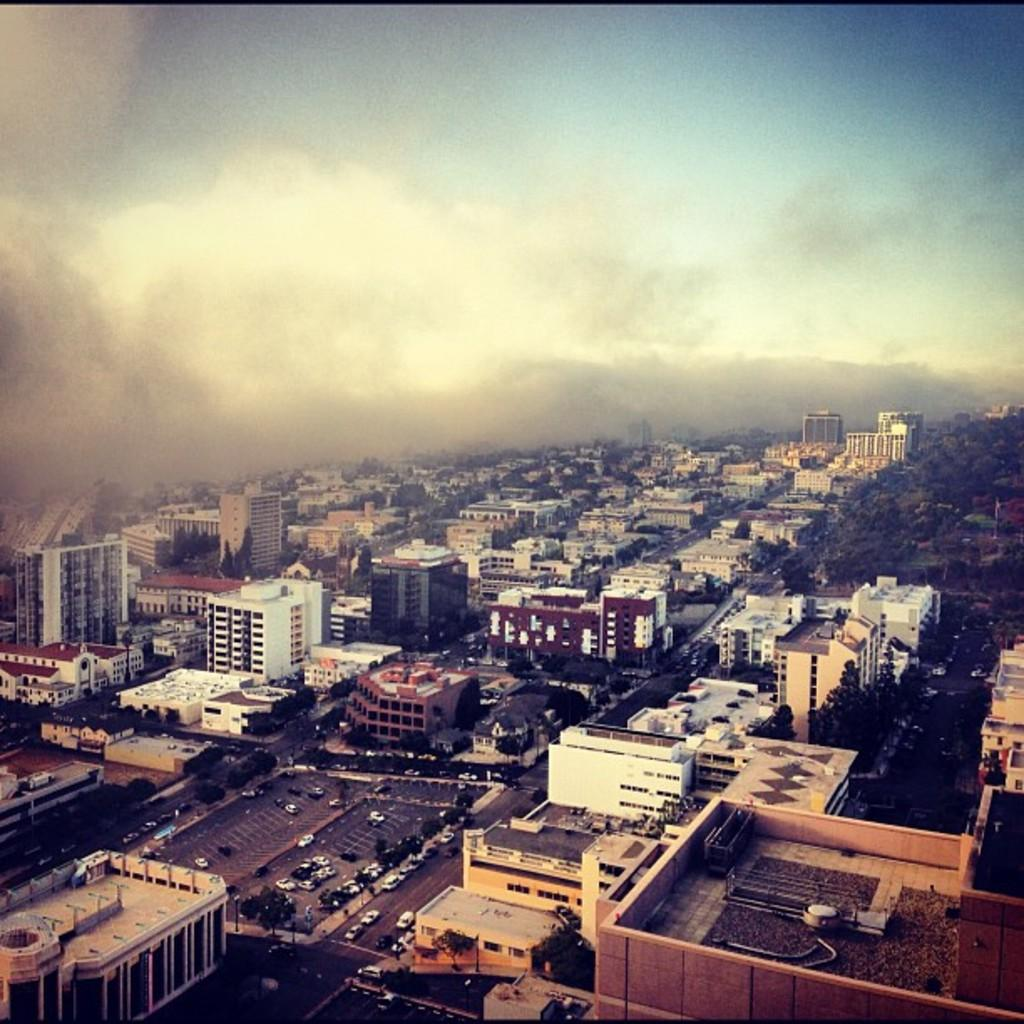What type of structures can be seen in the image? There are many buildings in the image. What other elements are present in the image besides buildings? There are trees, vehicles, a road, and smoke visible in the image. What is the sky's condition in the image? The sky is visible in the image. How many oranges are hanging from the trees in the image? There are no oranges present in the image; it features buildings, trees, vehicles, a road, smoke, and a visible sky. What type of bone can be seen in the image? There is no bone present in the image. 